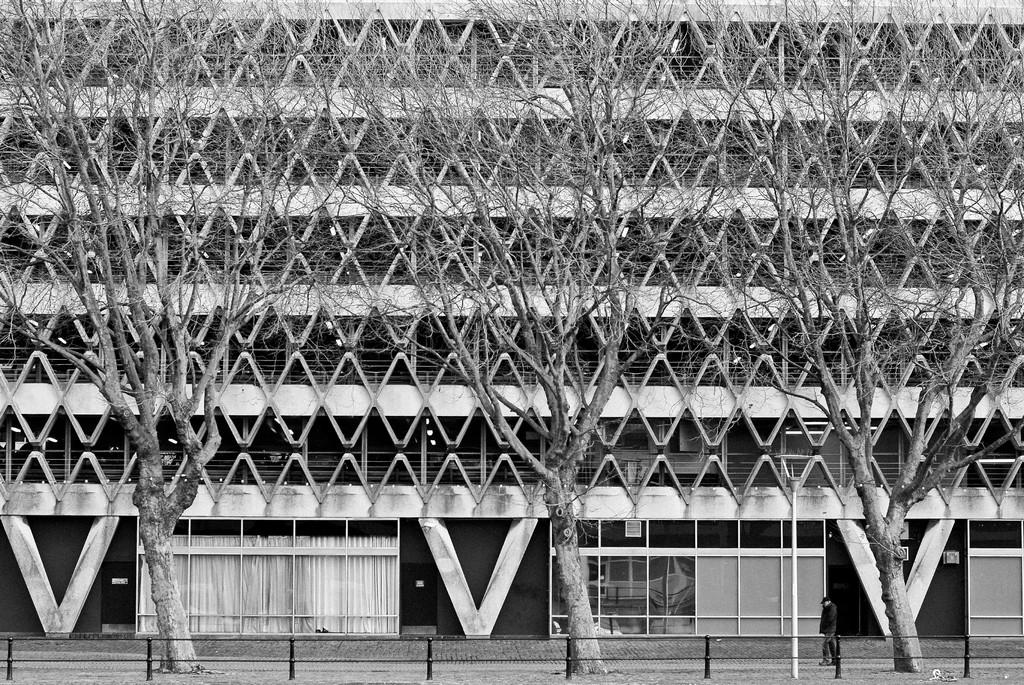What type of vegetation can be seen in the image? There are dry trees in the image. What type of structures are visible in the image? There are buildings in the image. What architectural feature can be seen in the buildings? There are windows in the image. What type of window treatment is present in the image? White color curtains are present in the image. What month is depicted in the image? There is no specific month depicted in the image; it only shows dry trees, buildings, windows, and white color curtains. What emotion is being expressed by the trees in the image? Trees do not express emotions, so it is not possible to determine any fear or other emotions from the image. 